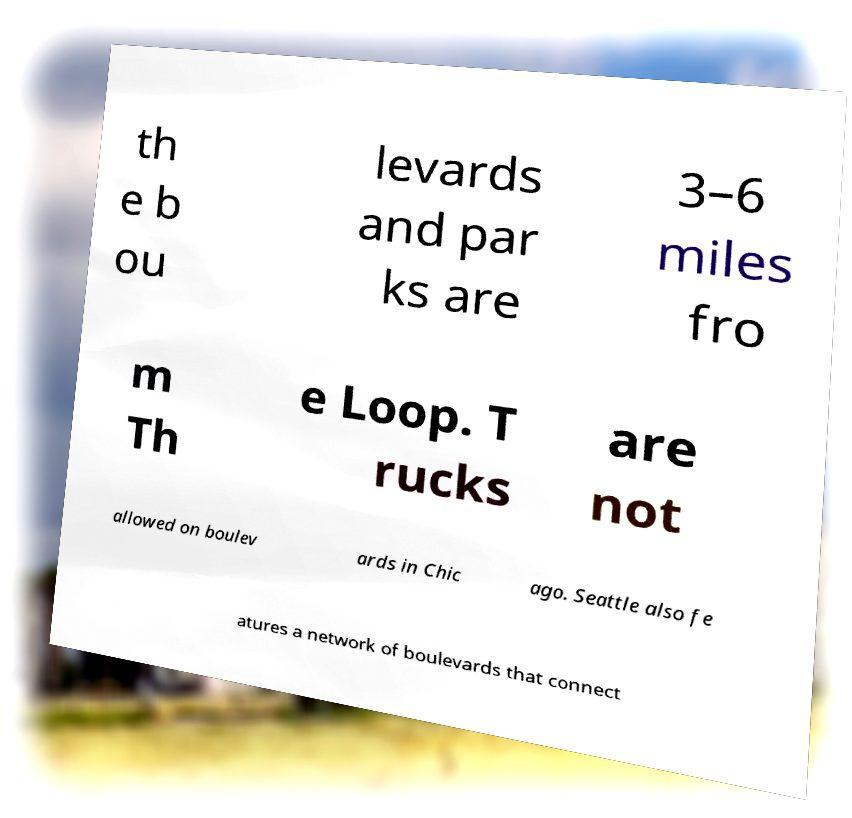I need the written content from this picture converted into text. Can you do that? th e b ou levards and par ks are 3–6 miles fro m Th e Loop. T rucks are not allowed on boulev ards in Chic ago. Seattle also fe atures a network of boulevards that connect 